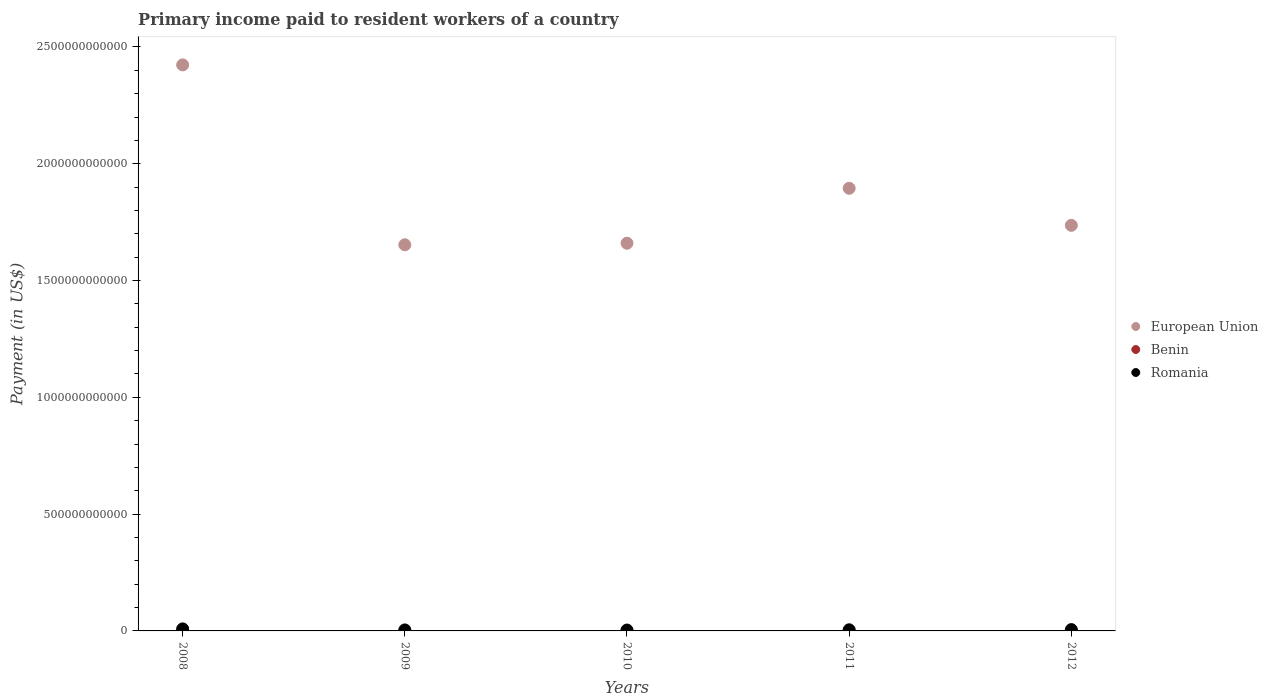How many different coloured dotlines are there?
Your answer should be very brief. 3. What is the amount paid to workers in Romania in 2011?
Keep it short and to the point. 4.86e+09. Across all years, what is the maximum amount paid to workers in European Union?
Keep it short and to the point. 2.42e+12. Across all years, what is the minimum amount paid to workers in Romania?
Provide a succinct answer. 3.75e+09. In which year was the amount paid to workers in Romania maximum?
Offer a terse response. 2008. What is the total amount paid to workers in Benin in the graph?
Keep it short and to the point. 5.13e+08. What is the difference between the amount paid to workers in Benin in 2008 and that in 2012?
Offer a terse response. -1.03e+08. What is the difference between the amount paid to workers in Benin in 2009 and the amount paid to workers in European Union in 2010?
Offer a very short reply. -1.66e+12. What is the average amount paid to workers in Romania per year?
Keep it short and to the point. 5.45e+09. In the year 2010, what is the difference between the amount paid to workers in Romania and amount paid to workers in European Union?
Provide a succinct answer. -1.66e+12. What is the ratio of the amount paid to workers in European Union in 2009 to that in 2011?
Give a very brief answer. 0.87. Is the difference between the amount paid to workers in Romania in 2008 and 2010 greater than the difference between the amount paid to workers in European Union in 2008 and 2010?
Give a very brief answer. No. What is the difference between the highest and the second highest amount paid to workers in Benin?
Provide a succinct answer. 3.99e+07. What is the difference between the highest and the lowest amount paid to workers in Benin?
Your answer should be compact. 1.03e+08. Is the sum of the amount paid to workers in Benin in 2009 and 2011 greater than the maximum amount paid to workers in Romania across all years?
Keep it short and to the point. No. Does the amount paid to workers in European Union monotonically increase over the years?
Provide a succinct answer. No. Is the amount paid to workers in Romania strictly less than the amount paid to workers in European Union over the years?
Your answer should be very brief. Yes. How many years are there in the graph?
Your answer should be compact. 5. What is the difference between two consecutive major ticks on the Y-axis?
Ensure brevity in your answer.  5.00e+11. How are the legend labels stacked?
Provide a short and direct response. Vertical. What is the title of the graph?
Ensure brevity in your answer.  Primary income paid to resident workers of a country. What is the label or title of the X-axis?
Your answer should be compact. Years. What is the label or title of the Y-axis?
Your response must be concise. Payment (in US$). What is the Payment (in US$) in European Union in 2008?
Offer a very short reply. 2.42e+12. What is the Payment (in US$) of Benin in 2008?
Provide a short and direct response. 5.62e+07. What is the Payment (in US$) of Romania in 2008?
Your answer should be compact. 8.70e+09. What is the Payment (in US$) in European Union in 2009?
Ensure brevity in your answer.  1.65e+12. What is the Payment (in US$) in Benin in 2009?
Provide a short and direct response. 7.61e+07. What is the Payment (in US$) of Romania in 2009?
Your response must be concise. 4.29e+09. What is the Payment (in US$) in European Union in 2010?
Provide a succinct answer. 1.66e+12. What is the Payment (in US$) of Benin in 2010?
Keep it short and to the point. 1.03e+08. What is the Payment (in US$) in Romania in 2010?
Give a very brief answer. 3.75e+09. What is the Payment (in US$) in European Union in 2011?
Make the answer very short. 1.89e+12. What is the Payment (in US$) in Benin in 2011?
Ensure brevity in your answer.  1.19e+08. What is the Payment (in US$) of Romania in 2011?
Offer a terse response. 4.86e+09. What is the Payment (in US$) in European Union in 2012?
Your response must be concise. 1.74e+12. What is the Payment (in US$) in Benin in 2012?
Make the answer very short. 1.59e+08. What is the Payment (in US$) in Romania in 2012?
Your response must be concise. 5.66e+09. Across all years, what is the maximum Payment (in US$) in European Union?
Offer a terse response. 2.42e+12. Across all years, what is the maximum Payment (in US$) of Benin?
Your response must be concise. 1.59e+08. Across all years, what is the maximum Payment (in US$) of Romania?
Offer a very short reply. 8.70e+09. Across all years, what is the minimum Payment (in US$) of European Union?
Provide a succinct answer. 1.65e+12. Across all years, what is the minimum Payment (in US$) in Benin?
Provide a short and direct response. 5.62e+07. Across all years, what is the minimum Payment (in US$) of Romania?
Offer a very short reply. 3.75e+09. What is the total Payment (in US$) of European Union in the graph?
Your response must be concise. 9.37e+12. What is the total Payment (in US$) of Benin in the graph?
Offer a terse response. 5.13e+08. What is the total Payment (in US$) in Romania in the graph?
Keep it short and to the point. 2.73e+1. What is the difference between the Payment (in US$) of European Union in 2008 and that in 2009?
Ensure brevity in your answer.  7.70e+11. What is the difference between the Payment (in US$) in Benin in 2008 and that in 2009?
Your response must be concise. -1.99e+07. What is the difference between the Payment (in US$) of Romania in 2008 and that in 2009?
Offer a terse response. 4.41e+09. What is the difference between the Payment (in US$) in European Union in 2008 and that in 2010?
Provide a succinct answer. 7.63e+11. What is the difference between the Payment (in US$) in Benin in 2008 and that in 2010?
Provide a succinct answer. -4.67e+07. What is the difference between the Payment (in US$) in Romania in 2008 and that in 2010?
Ensure brevity in your answer.  4.95e+09. What is the difference between the Payment (in US$) of European Union in 2008 and that in 2011?
Your answer should be compact. 5.28e+11. What is the difference between the Payment (in US$) in Benin in 2008 and that in 2011?
Provide a short and direct response. -6.28e+07. What is the difference between the Payment (in US$) of Romania in 2008 and that in 2011?
Offer a terse response. 3.84e+09. What is the difference between the Payment (in US$) of European Union in 2008 and that in 2012?
Your answer should be very brief. 6.87e+11. What is the difference between the Payment (in US$) of Benin in 2008 and that in 2012?
Your answer should be very brief. -1.03e+08. What is the difference between the Payment (in US$) of Romania in 2008 and that in 2012?
Your answer should be compact. 3.04e+09. What is the difference between the Payment (in US$) in European Union in 2009 and that in 2010?
Your answer should be very brief. -6.65e+09. What is the difference between the Payment (in US$) in Benin in 2009 and that in 2010?
Keep it short and to the point. -2.68e+07. What is the difference between the Payment (in US$) of Romania in 2009 and that in 2010?
Your answer should be very brief. 5.41e+08. What is the difference between the Payment (in US$) of European Union in 2009 and that in 2011?
Keep it short and to the point. -2.42e+11. What is the difference between the Payment (in US$) of Benin in 2009 and that in 2011?
Provide a short and direct response. -4.29e+07. What is the difference between the Payment (in US$) in Romania in 2009 and that in 2011?
Provide a succinct answer. -5.71e+08. What is the difference between the Payment (in US$) of European Union in 2009 and that in 2012?
Keep it short and to the point. -8.32e+1. What is the difference between the Payment (in US$) in Benin in 2009 and that in 2012?
Your response must be concise. -8.29e+07. What is the difference between the Payment (in US$) of Romania in 2009 and that in 2012?
Your answer should be very brief. -1.37e+09. What is the difference between the Payment (in US$) in European Union in 2010 and that in 2011?
Your answer should be very brief. -2.35e+11. What is the difference between the Payment (in US$) in Benin in 2010 and that in 2011?
Keep it short and to the point. -1.62e+07. What is the difference between the Payment (in US$) of Romania in 2010 and that in 2011?
Your response must be concise. -1.11e+09. What is the difference between the Payment (in US$) of European Union in 2010 and that in 2012?
Your answer should be compact. -7.66e+1. What is the difference between the Payment (in US$) in Benin in 2010 and that in 2012?
Provide a short and direct response. -5.61e+07. What is the difference between the Payment (in US$) of Romania in 2010 and that in 2012?
Your answer should be very brief. -1.92e+09. What is the difference between the Payment (in US$) of European Union in 2011 and that in 2012?
Provide a short and direct response. 1.59e+11. What is the difference between the Payment (in US$) of Benin in 2011 and that in 2012?
Offer a very short reply. -3.99e+07. What is the difference between the Payment (in US$) of Romania in 2011 and that in 2012?
Give a very brief answer. -8.03e+08. What is the difference between the Payment (in US$) in European Union in 2008 and the Payment (in US$) in Benin in 2009?
Ensure brevity in your answer.  2.42e+12. What is the difference between the Payment (in US$) of European Union in 2008 and the Payment (in US$) of Romania in 2009?
Keep it short and to the point. 2.42e+12. What is the difference between the Payment (in US$) of Benin in 2008 and the Payment (in US$) of Romania in 2009?
Your response must be concise. -4.23e+09. What is the difference between the Payment (in US$) of European Union in 2008 and the Payment (in US$) of Benin in 2010?
Offer a terse response. 2.42e+12. What is the difference between the Payment (in US$) in European Union in 2008 and the Payment (in US$) in Romania in 2010?
Your response must be concise. 2.42e+12. What is the difference between the Payment (in US$) in Benin in 2008 and the Payment (in US$) in Romania in 2010?
Provide a short and direct response. -3.69e+09. What is the difference between the Payment (in US$) of European Union in 2008 and the Payment (in US$) of Benin in 2011?
Provide a short and direct response. 2.42e+12. What is the difference between the Payment (in US$) in European Union in 2008 and the Payment (in US$) in Romania in 2011?
Provide a succinct answer. 2.42e+12. What is the difference between the Payment (in US$) of Benin in 2008 and the Payment (in US$) of Romania in 2011?
Your response must be concise. -4.80e+09. What is the difference between the Payment (in US$) of European Union in 2008 and the Payment (in US$) of Benin in 2012?
Keep it short and to the point. 2.42e+12. What is the difference between the Payment (in US$) in European Union in 2008 and the Payment (in US$) in Romania in 2012?
Offer a very short reply. 2.42e+12. What is the difference between the Payment (in US$) in Benin in 2008 and the Payment (in US$) in Romania in 2012?
Give a very brief answer. -5.61e+09. What is the difference between the Payment (in US$) in European Union in 2009 and the Payment (in US$) in Benin in 2010?
Keep it short and to the point. 1.65e+12. What is the difference between the Payment (in US$) in European Union in 2009 and the Payment (in US$) in Romania in 2010?
Offer a very short reply. 1.65e+12. What is the difference between the Payment (in US$) in Benin in 2009 and the Payment (in US$) in Romania in 2010?
Offer a terse response. -3.67e+09. What is the difference between the Payment (in US$) in European Union in 2009 and the Payment (in US$) in Benin in 2011?
Offer a terse response. 1.65e+12. What is the difference between the Payment (in US$) in European Union in 2009 and the Payment (in US$) in Romania in 2011?
Provide a short and direct response. 1.65e+12. What is the difference between the Payment (in US$) in Benin in 2009 and the Payment (in US$) in Romania in 2011?
Give a very brief answer. -4.78e+09. What is the difference between the Payment (in US$) in European Union in 2009 and the Payment (in US$) in Benin in 2012?
Provide a succinct answer. 1.65e+12. What is the difference between the Payment (in US$) in European Union in 2009 and the Payment (in US$) in Romania in 2012?
Provide a short and direct response. 1.65e+12. What is the difference between the Payment (in US$) of Benin in 2009 and the Payment (in US$) of Romania in 2012?
Provide a succinct answer. -5.59e+09. What is the difference between the Payment (in US$) of European Union in 2010 and the Payment (in US$) of Benin in 2011?
Ensure brevity in your answer.  1.66e+12. What is the difference between the Payment (in US$) of European Union in 2010 and the Payment (in US$) of Romania in 2011?
Ensure brevity in your answer.  1.65e+12. What is the difference between the Payment (in US$) in Benin in 2010 and the Payment (in US$) in Romania in 2011?
Provide a succinct answer. -4.76e+09. What is the difference between the Payment (in US$) of European Union in 2010 and the Payment (in US$) of Benin in 2012?
Your answer should be compact. 1.66e+12. What is the difference between the Payment (in US$) in European Union in 2010 and the Payment (in US$) in Romania in 2012?
Offer a terse response. 1.65e+12. What is the difference between the Payment (in US$) in Benin in 2010 and the Payment (in US$) in Romania in 2012?
Your response must be concise. -5.56e+09. What is the difference between the Payment (in US$) in European Union in 2011 and the Payment (in US$) in Benin in 2012?
Offer a very short reply. 1.89e+12. What is the difference between the Payment (in US$) in European Union in 2011 and the Payment (in US$) in Romania in 2012?
Offer a very short reply. 1.89e+12. What is the difference between the Payment (in US$) of Benin in 2011 and the Payment (in US$) of Romania in 2012?
Offer a very short reply. -5.54e+09. What is the average Payment (in US$) in European Union per year?
Provide a short and direct response. 1.87e+12. What is the average Payment (in US$) of Benin per year?
Your answer should be very brief. 1.03e+08. What is the average Payment (in US$) of Romania per year?
Provide a succinct answer. 5.45e+09. In the year 2008, what is the difference between the Payment (in US$) in European Union and Payment (in US$) in Benin?
Offer a very short reply. 2.42e+12. In the year 2008, what is the difference between the Payment (in US$) in European Union and Payment (in US$) in Romania?
Make the answer very short. 2.41e+12. In the year 2008, what is the difference between the Payment (in US$) of Benin and Payment (in US$) of Romania?
Your answer should be very brief. -8.65e+09. In the year 2009, what is the difference between the Payment (in US$) in European Union and Payment (in US$) in Benin?
Give a very brief answer. 1.65e+12. In the year 2009, what is the difference between the Payment (in US$) of European Union and Payment (in US$) of Romania?
Provide a succinct answer. 1.65e+12. In the year 2009, what is the difference between the Payment (in US$) of Benin and Payment (in US$) of Romania?
Make the answer very short. -4.21e+09. In the year 2010, what is the difference between the Payment (in US$) of European Union and Payment (in US$) of Benin?
Ensure brevity in your answer.  1.66e+12. In the year 2010, what is the difference between the Payment (in US$) in European Union and Payment (in US$) in Romania?
Keep it short and to the point. 1.66e+12. In the year 2010, what is the difference between the Payment (in US$) of Benin and Payment (in US$) of Romania?
Give a very brief answer. -3.65e+09. In the year 2011, what is the difference between the Payment (in US$) of European Union and Payment (in US$) of Benin?
Your response must be concise. 1.89e+12. In the year 2011, what is the difference between the Payment (in US$) in European Union and Payment (in US$) in Romania?
Provide a succinct answer. 1.89e+12. In the year 2011, what is the difference between the Payment (in US$) of Benin and Payment (in US$) of Romania?
Provide a succinct answer. -4.74e+09. In the year 2012, what is the difference between the Payment (in US$) of European Union and Payment (in US$) of Benin?
Offer a terse response. 1.74e+12. In the year 2012, what is the difference between the Payment (in US$) in European Union and Payment (in US$) in Romania?
Make the answer very short. 1.73e+12. In the year 2012, what is the difference between the Payment (in US$) of Benin and Payment (in US$) of Romania?
Give a very brief answer. -5.50e+09. What is the ratio of the Payment (in US$) in European Union in 2008 to that in 2009?
Give a very brief answer. 1.47. What is the ratio of the Payment (in US$) in Benin in 2008 to that in 2009?
Offer a very short reply. 0.74. What is the ratio of the Payment (in US$) in Romania in 2008 to that in 2009?
Keep it short and to the point. 2.03. What is the ratio of the Payment (in US$) of European Union in 2008 to that in 2010?
Keep it short and to the point. 1.46. What is the ratio of the Payment (in US$) of Benin in 2008 to that in 2010?
Your answer should be compact. 0.55. What is the ratio of the Payment (in US$) of Romania in 2008 to that in 2010?
Offer a terse response. 2.32. What is the ratio of the Payment (in US$) of European Union in 2008 to that in 2011?
Keep it short and to the point. 1.28. What is the ratio of the Payment (in US$) in Benin in 2008 to that in 2011?
Offer a very short reply. 0.47. What is the ratio of the Payment (in US$) in Romania in 2008 to that in 2011?
Offer a terse response. 1.79. What is the ratio of the Payment (in US$) in European Union in 2008 to that in 2012?
Your response must be concise. 1.4. What is the ratio of the Payment (in US$) of Benin in 2008 to that in 2012?
Provide a short and direct response. 0.35. What is the ratio of the Payment (in US$) in Romania in 2008 to that in 2012?
Offer a very short reply. 1.54. What is the ratio of the Payment (in US$) of European Union in 2009 to that in 2010?
Keep it short and to the point. 1. What is the ratio of the Payment (in US$) in Benin in 2009 to that in 2010?
Keep it short and to the point. 0.74. What is the ratio of the Payment (in US$) of Romania in 2009 to that in 2010?
Your answer should be compact. 1.14. What is the ratio of the Payment (in US$) in European Union in 2009 to that in 2011?
Provide a succinct answer. 0.87. What is the ratio of the Payment (in US$) of Benin in 2009 to that in 2011?
Give a very brief answer. 0.64. What is the ratio of the Payment (in US$) of Romania in 2009 to that in 2011?
Offer a very short reply. 0.88. What is the ratio of the Payment (in US$) in European Union in 2009 to that in 2012?
Offer a terse response. 0.95. What is the ratio of the Payment (in US$) in Benin in 2009 to that in 2012?
Offer a very short reply. 0.48. What is the ratio of the Payment (in US$) of Romania in 2009 to that in 2012?
Offer a terse response. 0.76. What is the ratio of the Payment (in US$) of European Union in 2010 to that in 2011?
Your answer should be very brief. 0.88. What is the ratio of the Payment (in US$) in Benin in 2010 to that in 2011?
Provide a short and direct response. 0.86. What is the ratio of the Payment (in US$) of Romania in 2010 to that in 2011?
Your response must be concise. 0.77. What is the ratio of the Payment (in US$) of European Union in 2010 to that in 2012?
Offer a very short reply. 0.96. What is the ratio of the Payment (in US$) of Benin in 2010 to that in 2012?
Your answer should be compact. 0.65. What is the ratio of the Payment (in US$) of Romania in 2010 to that in 2012?
Provide a short and direct response. 0.66. What is the ratio of the Payment (in US$) in European Union in 2011 to that in 2012?
Provide a succinct answer. 1.09. What is the ratio of the Payment (in US$) in Benin in 2011 to that in 2012?
Your answer should be compact. 0.75. What is the ratio of the Payment (in US$) of Romania in 2011 to that in 2012?
Provide a succinct answer. 0.86. What is the difference between the highest and the second highest Payment (in US$) of European Union?
Your response must be concise. 5.28e+11. What is the difference between the highest and the second highest Payment (in US$) in Benin?
Ensure brevity in your answer.  3.99e+07. What is the difference between the highest and the second highest Payment (in US$) in Romania?
Give a very brief answer. 3.04e+09. What is the difference between the highest and the lowest Payment (in US$) of European Union?
Your answer should be very brief. 7.70e+11. What is the difference between the highest and the lowest Payment (in US$) in Benin?
Your response must be concise. 1.03e+08. What is the difference between the highest and the lowest Payment (in US$) in Romania?
Provide a succinct answer. 4.95e+09. 